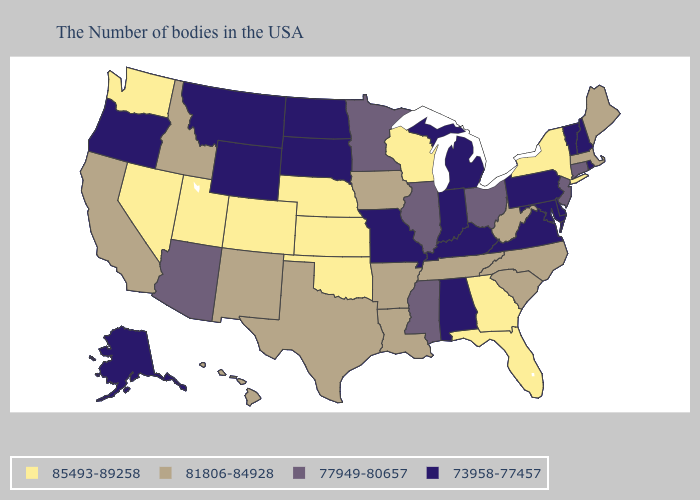Does North Carolina have a lower value than Alaska?
Short answer required. No. Does Illinois have the lowest value in the MidWest?
Be succinct. No. How many symbols are there in the legend?
Be succinct. 4. Is the legend a continuous bar?
Be succinct. No. What is the highest value in the MidWest ?
Be succinct. 85493-89258. How many symbols are there in the legend?
Write a very short answer. 4. What is the lowest value in the West?
Give a very brief answer. 73958-77457. What is the value of Mississippi?
Be succinct. 77949-80657. Name the states that have a value in the range 81806-84928?
Give a very brief answer. Maine, Massachusetts, North Carolina, South Carolina, West Virginia, Tennessee, Louisiana, Arkansas, Iowa, Texas, New Mexico, Idaho, California, Hawaii. What is the highest value in the West ?
Write a very short answer. 85493-89258. Does North Carolina have the same value as Tennessee?
Write a very short answer. Yes. Name the states that have a value in the range 77949-80657?
Be succinct. Connecticut, New Jersey, Ohio, Illinois, Mississippi, Minnesota, Arizona. What is the value of Louisiana?
Be succinct. 81806-84928. Does Minnesota have a lower value than Alabama?
Concise answer only. No. What is the value of Pennsylvania?
Give a very brief answer. 73958-77457. 